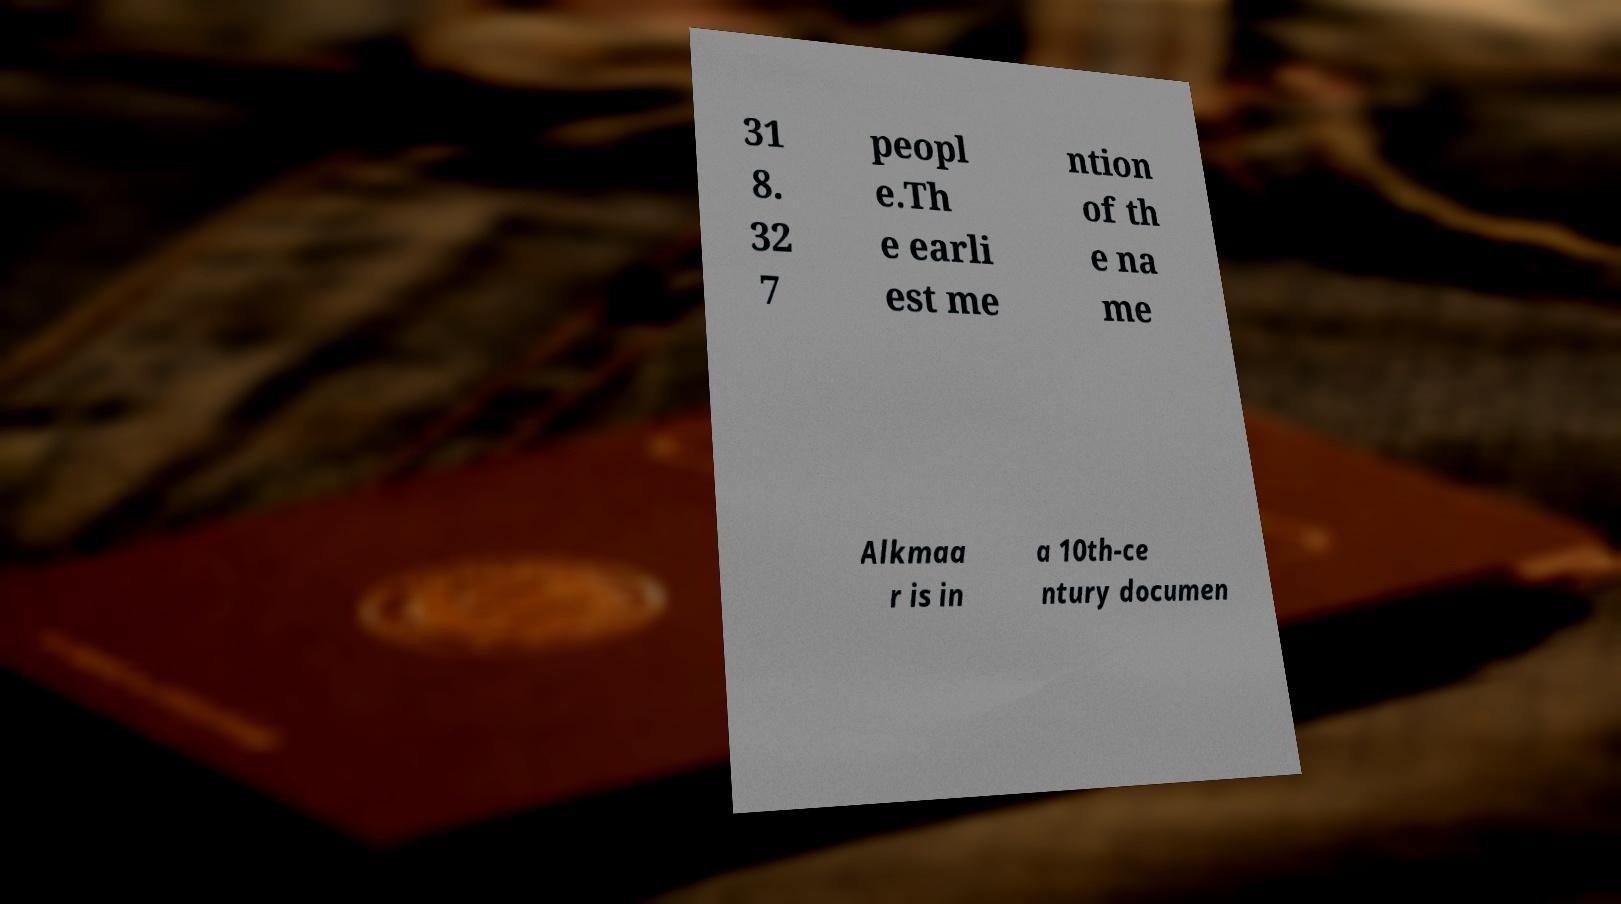Can you read and provide the text displayed in the image?This photo seems to have some interesting text. Can you extract and type it out for me? 31 8. 32 7 peopl e.Th e earli est me ntion of th e na me Alkmaa r is in a 10th-ce ntury documen 